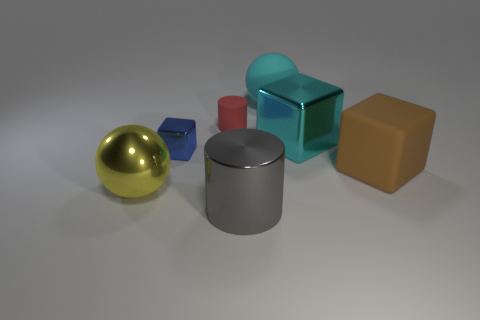The cylinder in front of the cylinder behind the cube in front of the tiny block is what color?
Make the answer very short. Gray. What size is the shiny thing that is behind the gray thing and to the right of the small cylinder?
Ensure brevity in your answer.  Large. What number of other objects are there of the same shape as the tiny blue metal object?
Make the answer very short. 2. How many cylinders are either big brown objects or blue shiny things?
Keep it short and to the point. 0. There is a big sphere in front of the rubber thing that is on the right side of the cyan ball; is there a large rubber ball left of it?
Give a very brief answer. No. There is another thing that is the same shape as the red object; what is its color?
Give a very brief answer. Gray. How many yellow objects are either cylinders or big metallic cylinders?
Ensure brevity in your answer.  0. There is a large ball behind the small thing in front of the tiny rubber thing; what is its material?
Your answer should be compact. Rubber. Is the shape of the yellow metallic thing the same as the tiny rubber object?
Your answer should be compact. No. There is a rubber ball that is the same size as the gray cylinder; what color is it?
Give a very brief answer. Cyan. 